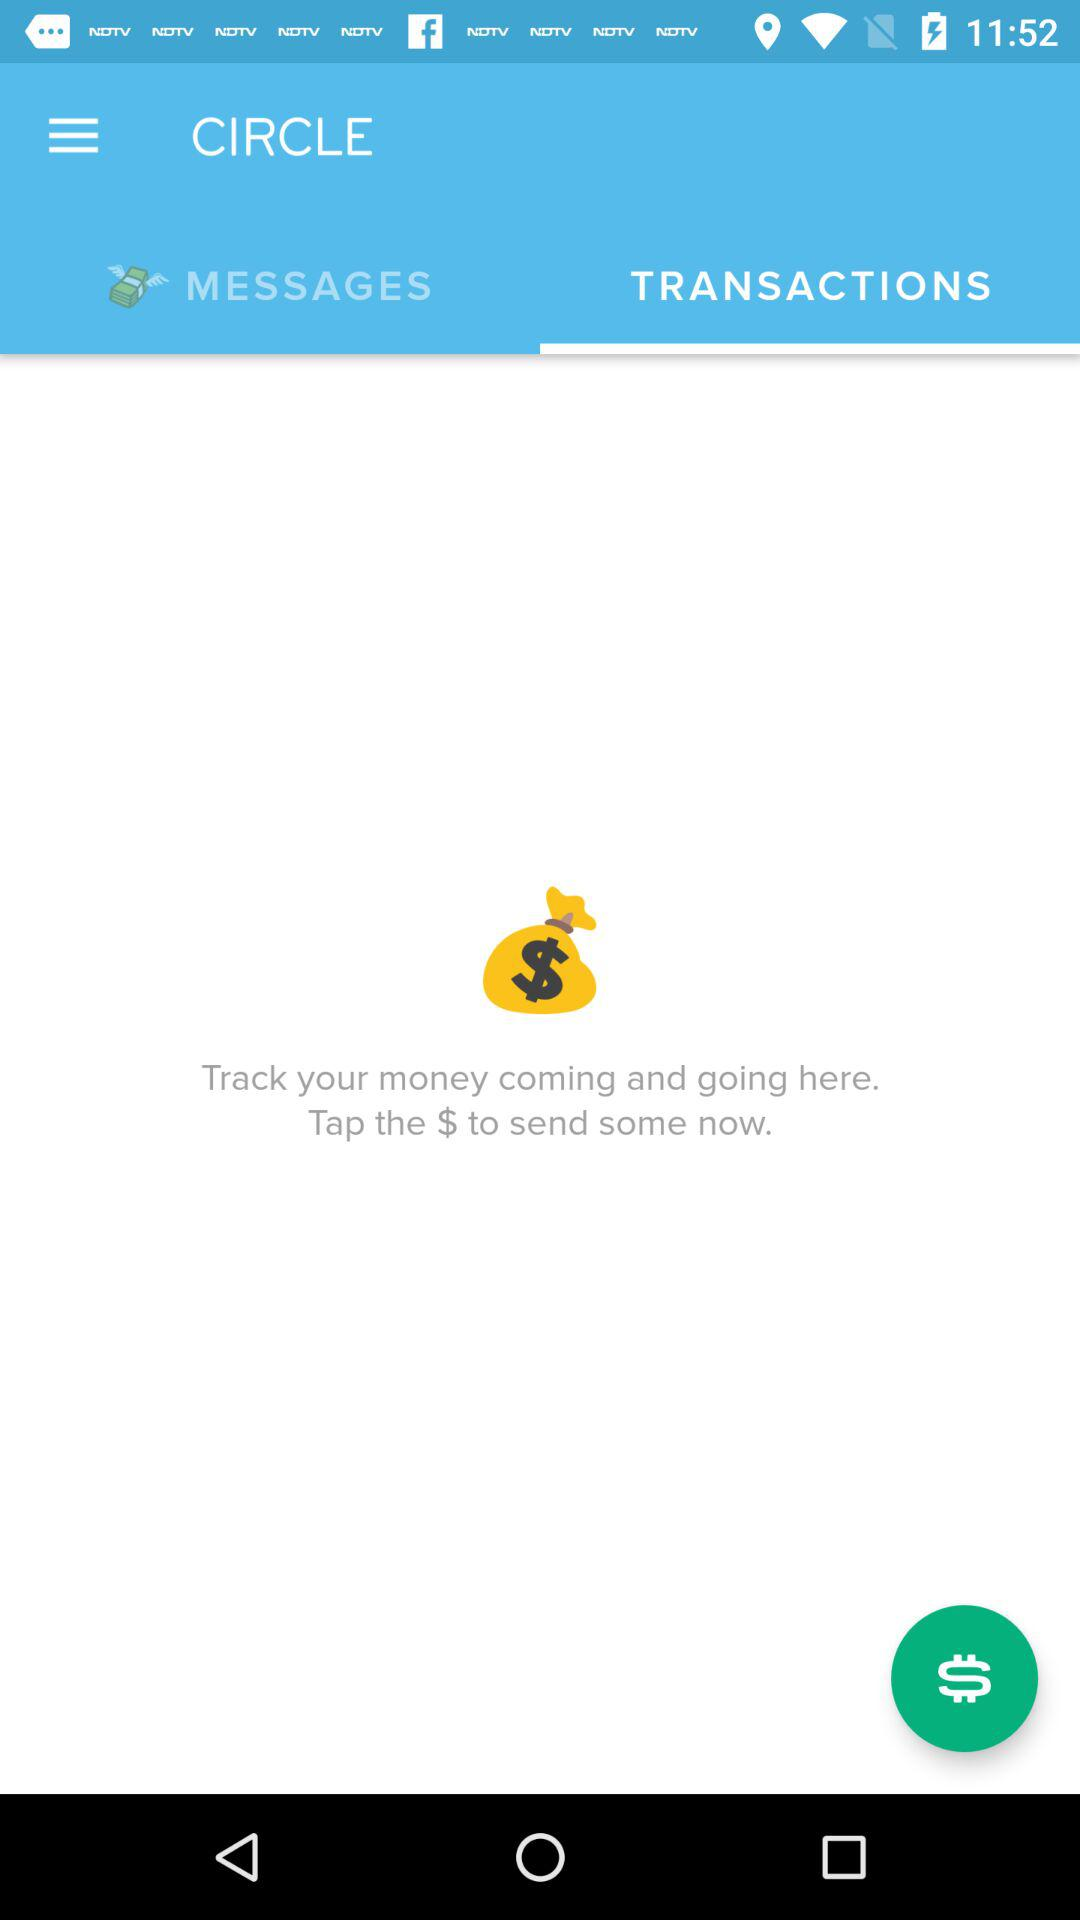Which tab is selected? The selected tab is "TRANSACTIONS". 